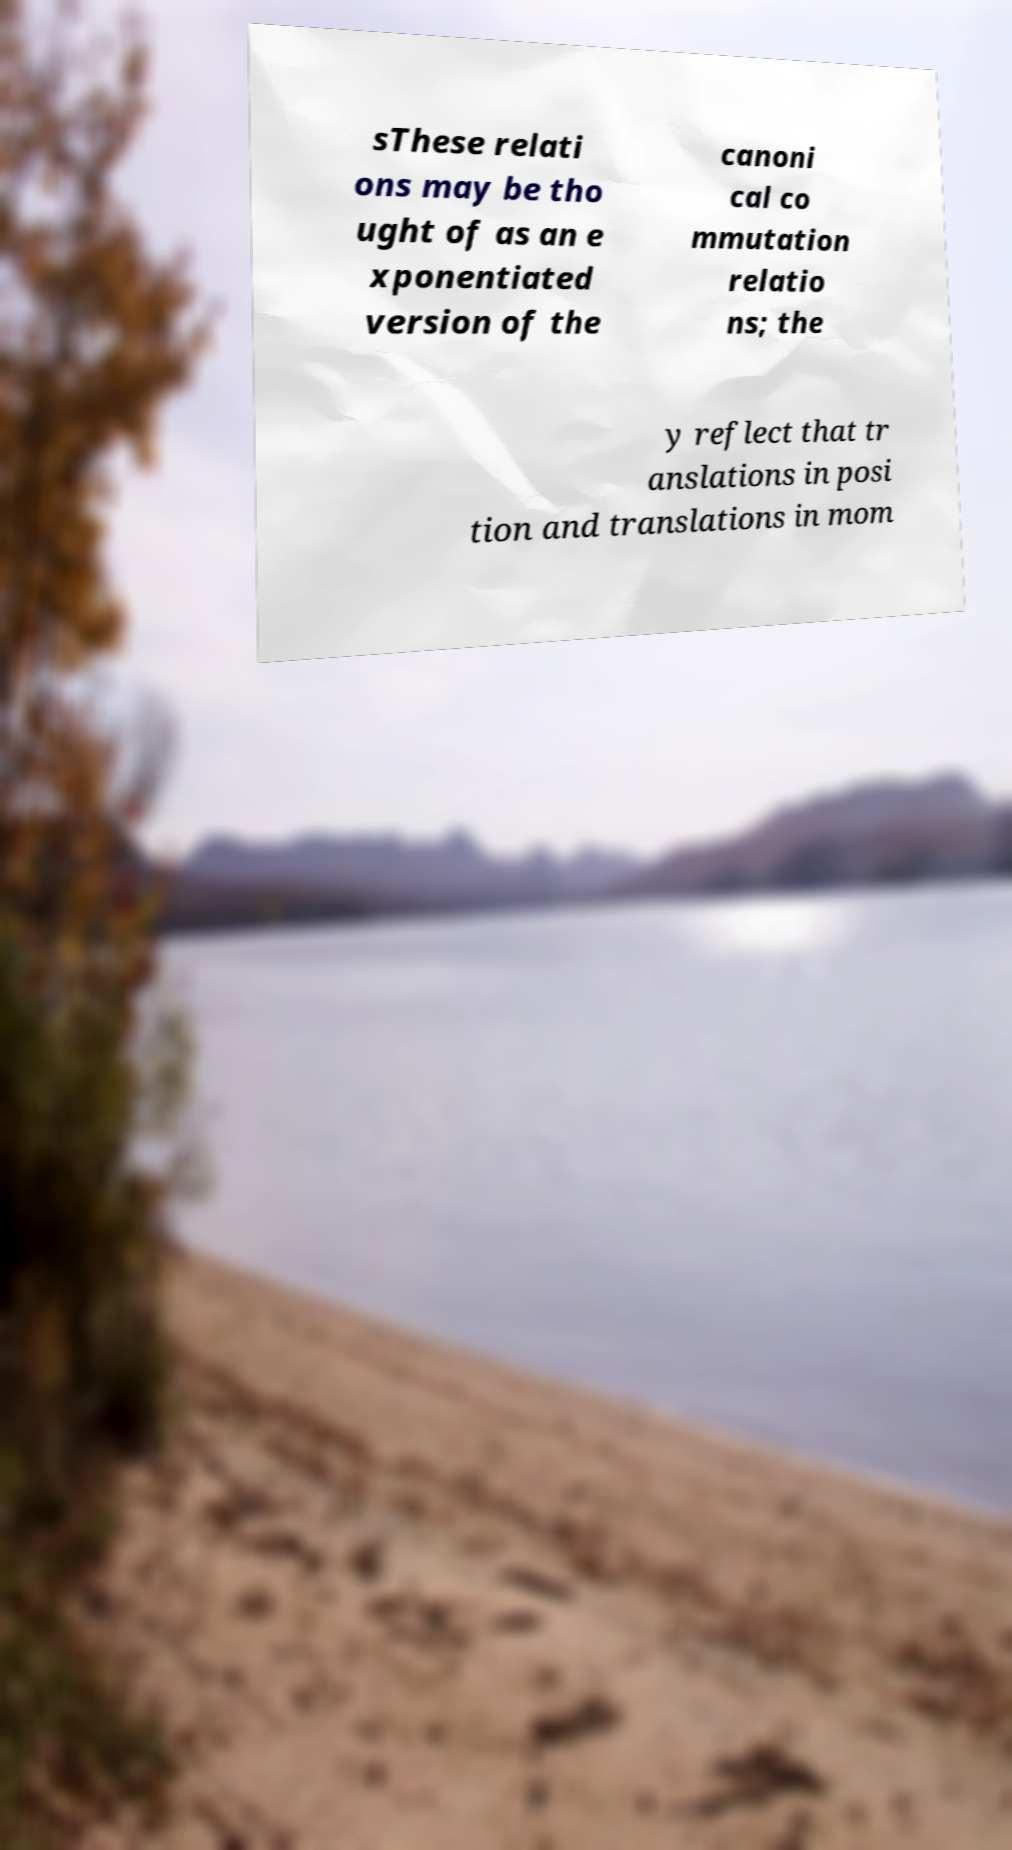For documentation purposes, I need the text within this image transcribed. Could you provide that? sThese relati ons may be tho ught of as an e xponentiated version of the canoni cal co mmutation relatio ns; the y reflect that tr anslations in posi tion and translations in mom 